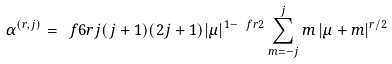<formula> <loc_0><loc_0><loc_500><loc_500>\alpha ^ { ( r , j ) } = \ f { 6 } { r j ( j + 1 ) ( 2 j + 1 ) } | \mu | ^ { 1 - \ f { r } { 2 } } \sum _ { m = - j } ^ { j } { m \left | \mu + m \right | ^ { r / 2 } }</formula> 